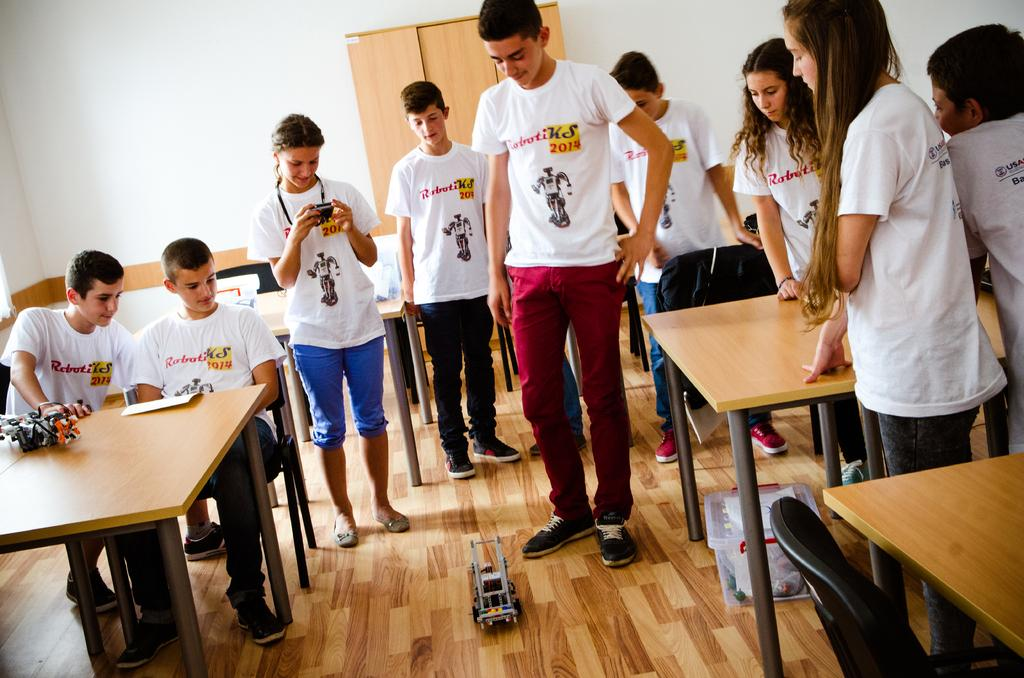How many people are in the image? There are people in the image, but the exact number is not specified. What are the positions of the people in the image? Two of the people are sitting, and the rest are standing. What type of furniture is present in the image? There are tables in the image. What object can be found on the floor in the image? There is a toy on the floor. What type of yak can be seen interacting with the toy on the floor? There is no yak present in the image; it only features people, tables, and a toy on the floor. What is the friction between the toy and the floor in the image? The facts provided do not give any information about the friction between the toy and the floor, so it cannot be determined from the image. 